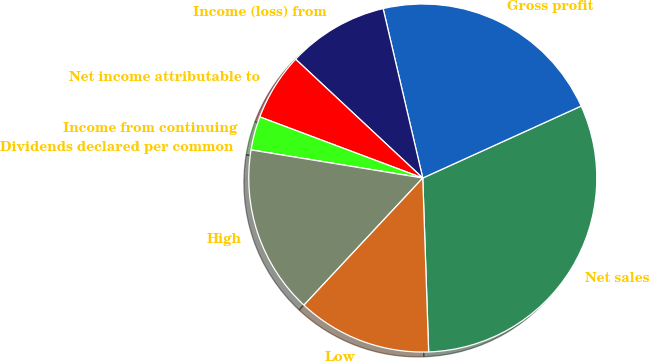Convert chart to OTSL. <chart><loc_0><loc_0><loc_500><loc_500><pie_chart><fcel>Net sales<fcel>Gross profit<fcel>Income (loss) from<fcel>Net income attributable to<fcel>Income from continuing<fcel>Dividends declared per common<fcel>High<fcel>Low<nl><fcel>31.25%<fcel>21.87%<fcel>9.38%<fcel>6.25%<fcel>3.13%<fcel>0.0%<fcel>15.62%<fcel>12.5%<nl></chart> 